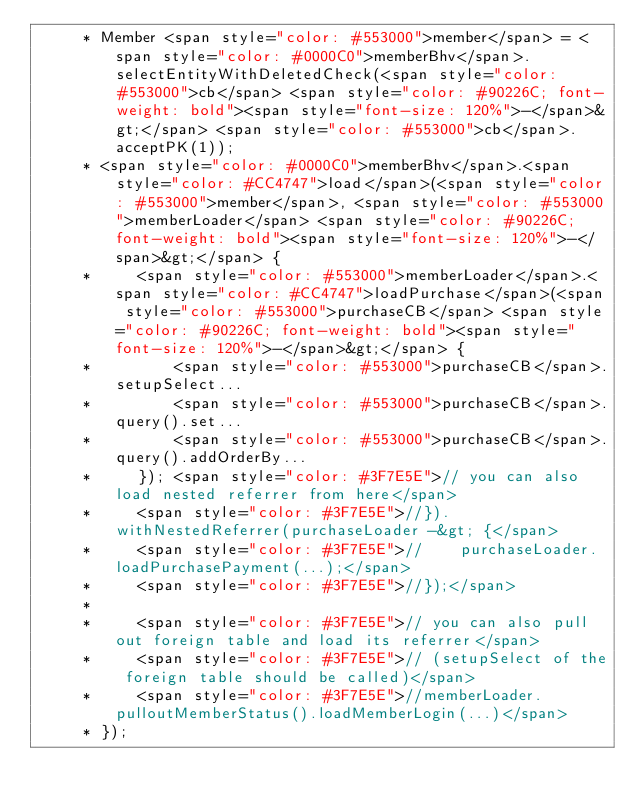<code> <loc_0><loc_0><loc_500><loc_500><_Java_>     * Member <span style="color: #553000">member</span> = <span style="color: #0000C0">memberBhv</span>.selectEntityWithDeletedCheck(<span style="color: #553000">cb</span> <span style="color: #90226C; font-weight: bold"><span style="font-size: 120%">-</span>&gt;</span> <span style="color: #553000">cb</span>.acceptPK(1));
     * <span style="color: #0000C0">memberBhv</span>.<span style="color: #CC4747">load</span>(<span style="color: #553000">member</span>, <span style="color: #553000">memberLoader</span> <span style="color: #90226C; font-weight: bold"><span style="font-size: 120%">-</span>&gt;</span> {
     *     <span style="color: #553000">memberLoader</span>.<span style="color: #CC4747">loadPurchase</span>(<span style="color: #553000">purchaseCB</span> <span style="color: #90226C; font-weight: bold"><span style="font-size: 120%">-</span>&gt;</span> {
     *         <span style="color: #553000">purchaseCB</span>.setupSelect...
     *         <span style="color: #553000">purchaseCB</span>.query().set...
     *         <span style="color: #553000">purchaseCB</span>.query().addOrderBy...
     *     }); <span style="color: #3F7E5E">// you can also load nested referrer from here</span>
     *     <span style="color: #3F7E5E">//}).withNestedReferrer(purchaseLoader -&gt; {</span>
     *     <span style="color: #3F7E5E">//    purchaseLoader.loadPurchasePayment(...);</span>
     *     <span style="color: #3F7E5E">//});</span>
     *
     *     <span style="color: #3F7E5E">// you can also pull out foreign table and load its referrer</span>
     *     <span style="color: #3F7E5E">// (setupSelect of the foreign table should be called)</span>
     *     <span style="color: #3F7E5E">//memberLoader.pulloutMemberStatus().loadMemberLogin(...)</span>
     * });</code> 